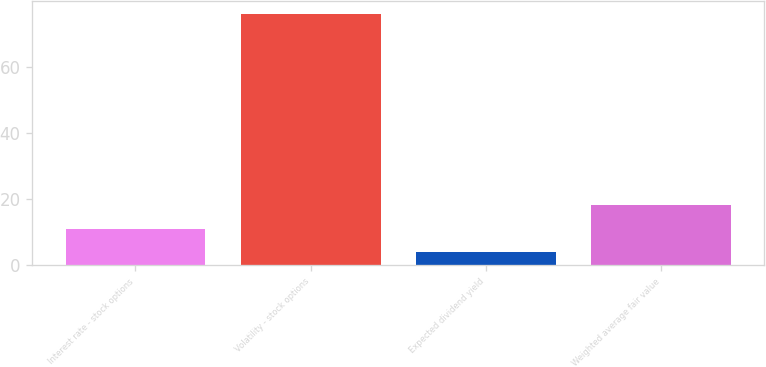<chart> <loc_0><loc_0><loc_500><loc_500><bar_chart><fcel>Interest rate - stock options<fcel>Volatility - stock options<fcel>Expected dividend yield<fcel>Weighted average fair value<nl><fcel>11.09<fcel>76<fcel>3.88<fcel>18.3<nl></chart> 